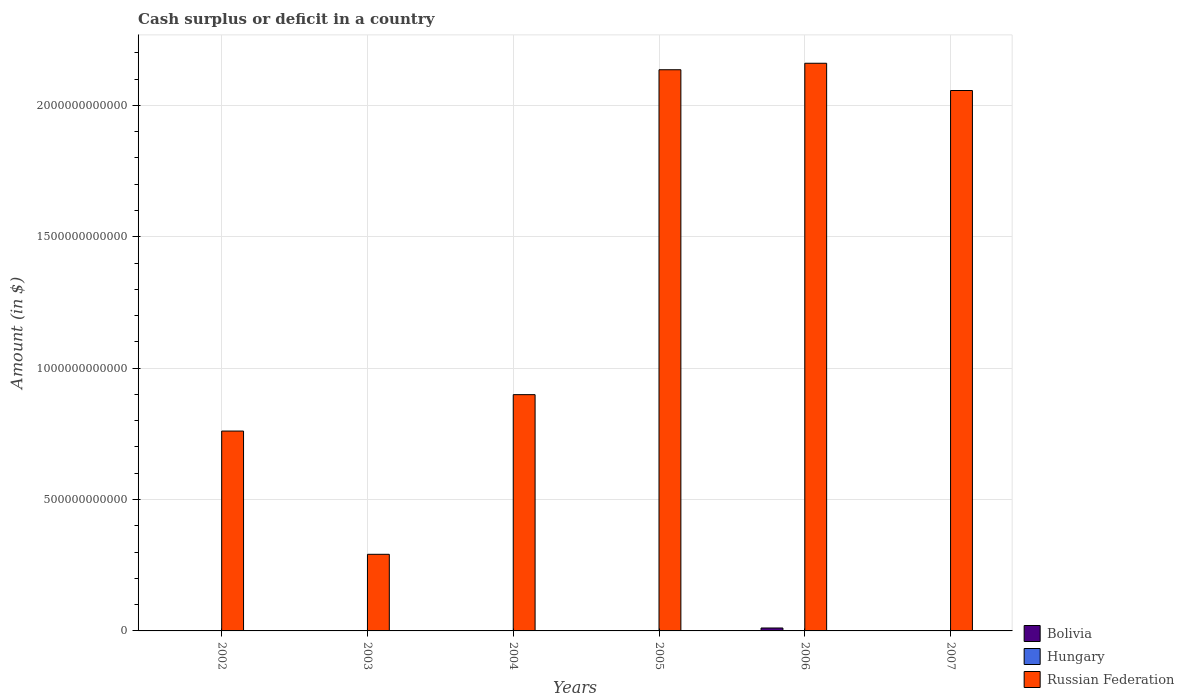Are the number of bars on each tick of the X-axis equal?
Provide a succinct answer. No. How many bars are there on the 1st tick from the left?
Keep it short and to the point. 1. How many bars are there on the 4th tick from the right?
Offer a terse response. 1. What is the amount of cash surplus or deficit in Russian Federation in 2002?
Offer a very short reply. 7.61e+11. Across all years, what is the maximum amount of cash surplus or deficit in Bolivia?
Your answer should be very brief. 1.12e+1. Across all years, what is the minimum amount of cash surplus or deficit in Hungary?
Ensure brevity in your answer.  0. In which year was the amount of cash surplus or deficit in Russian Federation maximum?
Give a very brief answer. 2006. What is the total amount of cash surplus or deficit in Russian Federation in the graph?
Give a very brief answer. 8.30e+12. What is the difference between the amount of cash surplus or deficit in Russian Federation in 2005 and that in 2006?
Your answer should be compact. -2.47e+1. What is the difference between the amount of cash surplus or deficit in Bolivia in 2003 and the amount of cash surplus or deficit in Russian Federation in 2005?
Keep it short and to the point. -2.14e+12. What is the average amount of cash surplus or deficit in Bolivia per year?
Give a very brief answer. 2.07e+09. In the year 2006, what is the difference between the amount of cash surplus or deficit in Bolivia and amount of cash surplus or deficit in Russian Federation?
Ensure brevity in your answer.  -2.15e+12. What is the ratio of the amount of cash surplus or deficit in Russian Federation in 2002 to that in 2004?
Your answer should be very brief. 0.85. Is the amount of cash surplus or deficit in Russian Federation in 2002 less than that in 2007?
Offer a very short reply. Yes. What is the difference between the highest and the second highest amount of cash surplus or deficit in Russian Federation?
Your answer should be compact. 2.47e+1. What is the difference between the highest and the lowest amount of cash surplus or deficit in Bolivia?
Offer a very short reply. 1.12e+1. Is the sum of the amount of cash surplus or deficit in Russian Federation in 2005 and 2006 greater than the maximum amount of cash surplus or deficit in Bolivia across all years?
Provide a short and direct response. Yes. How many bars are there?
Provide a short and direct response. 8. Are all the bars in the graph horizontal?
Provide a short and direct response. No. What is the difference between two consecutive major ticks on the Y-axis?
Offer a terse response. 5.00e+11. Are the values on the major ticks of Y-axis written in scientific E-notation?
Provide a succinct answer. No. Does the graph contain grids?
Your answer should be compact. Yes. How are the legend labels stacked?
Make the answer very short. Vertical. What is the title of the graph?
Provide a succinct answer. Cash surplus or deficit in a country. What is the label or title of the X-axis?
Your answer should be very brief. Years. What is the label or title of the Y-axis?
Keep it short and to the point. Amount (in $). What is the Amount (in $) of Bolivia in 2002?
Provide a short and direct response. 0. What is the Amount (in $) in Russian Federation in 2002?
Make the answer very short. 7.61e+11. What is the Amount (in $) in Bolivia in 2003?
Keep it short and to the point. 0. What is the Amount (in $) in Russian Federation in 2003?
Provide a short and direct response. 2.92e+11. What is the Amount (in $) in Hungary in 2004?
Keep it short and to the point. 0. What is the Amount (in $) of Russian Federation in 2004?
Your response must be concise. 8.99e+11. What is the Amount (in $) of Bolivia in 2005?
Your answer should be compact. 0. What is the Amount (in $) in Hungary in 2005?
Offer a terse response. 0. What is the Amount (in $) of Russian Federation in 2005?
Ensure brevity in your answer.  2.14e+12. What is the Amount (in $) in Bolivia in 2006?
Your answer should be very brief. 1.12e+1. What is the Amount (in $) in Hungary in 2006?
Give a very brief answer. 0. What is the Amount (in $) of Russian Federation in 2006?
Make the answer very short. 2.16e+12. What is the Amount (in $) of Bolivia in 2007?
Your answer should be compact. 1.28e+09. What is the Amount (in $) of Russian Federation in 2007?
Ensure brevity in your answer.  2.06e+12. Across all years, what is the maximum Amount (in $) of Bolivia?
Your answer should be very brief. 1.12e+1. Across all years, what is the maximum Amount (in $) of Russian Federation?
Offer a terse response. 2.16e+12. Across all years, what is the minimum Amount (in $) of Russian Federation?
Provide a succinct answer. 2.92e+11. What is the total Amount (in $) in Bolivia in the graph?
Offer a terse response. 1.24e+1. What is the total Amount (in $) of Russian Federation in the graph?
Give a very brief answer. 8.30e+12. What is the difference between the Amount (in $) in Russian Federation in 2002 and that in 2003?
Ensure brevity in your answer.  4.69e+11. What is the difference between the Amount (in $) in Russian Federation in 2002 and that in 2004?
Ensure brevity in your answer.  -1.39e+11. What is the difference between the Amount (in $) in Russian Federation in 2002 and that in 2005?
Your response must be concise. -1.38e+12. What is the difference between the Amount (in $) of Russian Federation in 2002 and that in 2006?
Give a very brief answer. -1.40e+12. What is the difference between the Amount (in $) of Russian Federation in 2002 and that in 2007?
Provide a short and direct response. -1.30e+12. What is the difference between the Amount (in $) of Russian Federation in 2003 and that in 2004?
Your response must be concise. -6.08e+11. What is the difference between the Amount (in $) in Russian Federation in 2003 and that in 2005?
Your answer should be compact. -1.84e+12. What is the difference between the Amount (in $) in Russian Federation in 2003 and that in 2006?
Provide a short and direct response. -1.87e+12. What is the difference between the Amount (in $) of Russian Federation in 2003 and that in 2007?
Provide a short and direct response. -1.77e+12. What is the difference between the Amount (in $) in Russian Federation in 2004 and that in 2005?
Your answer should be compact. -1.24e+12. What is the difference between the Amount (in $) of Russian Federation in 2004 and that in 2006?
Give a very brief answer. -1.26e+12. What is the difference between the Amount (in $) of Russian Federation in 2004 and that in 2007?
Your response must be concise. -1.16e+12. What is the difference between the Amount (in $) of Russian Federation in 2005 and that in 2006?
Offer a very short reply. -2.47e+1. What is the difference between the Amount (in $) in Russian Federation in 2005 and that in 2007?
Your answer should be compact. 7.90e+1. What is the difference between the Amount (in $) in Bolivia in 2006 and that in 2007?
Offer a terse response. 9.88e+09. What is the difference between the Amount (in $) in Russian Federation in 2006 and that in 2007?
Offer a terse response. 1.04e+11. What is the difference between the Amount (in $) of Bolivia in 2006 and the Amount (in $) of Russian Federation in 2007?
Your answer should be compact. -2.05e+12. What is the average Amount (in $) in Bolivia per year?
Offer a very short reply. 2.07e+09. What is the average Amount (in $) in Hungary per year?
Keep it short and to the point. 0. What is the average Amount (in $) in Russian Federation per year?
Provide a succinct answer. 1.38e+12. In the year 2006, what is the difference between the Amount (in $) of Bolivia and Amount (in $) of Russian Federation?
Ensure brevity in your answer.  -2.15e+12. In the year 2007, what is the difference between the Amount (in $) in Bolivia and Amount (in $) in Russian Federation?
Your answer should be very brief. -2.06e+12. What is the ratio of the Amount (in $) in Russian Federation in 2002 to that in 2003?
Ensure brevity in your answer.  2.61. What is the ratio of the Amount (in $) of Russian Federation in 2002 to that in 2004?
Give a very brief answer. 0.85. What is the ratio of the Amount (in $) in Russian Federation in 2002 to that in 2005?
Keep it short and to the point. 0.36. What is the ratio of the Amount (in $) in Russian Federation in 2002 to that in 2006?
Provide a short and direct response. 0.35. What is the ratio of the Amount (in $) of Russian Federation in 2002 to that in 2007?
Give a very brief answer. 0.37. What is the ratio of the Amount (in $) in Russian Federation in 2003 to that in 2004?
Your answer should be compact. 0.32. What is the ratio of the Amount (in $) of Russian Federation in 2003 to that in 2005?
Your answer should be compact. 0.14. What is the ratio of the Amount (in $) in Russian Federation in 2003 to that in 2006?
Provide a succinct answer. 0.14. What is the ratio of the Amount (in $) in Russian Federation in 2003 to that in 2007?
Ensure brevity in your answer.  0.14. What is the ratio of the Amount (in $) in Russian Federation in 2004 to that in 2005?
Make the answer very short. 0.42. What is the ratio of the Amount (in $) of Russian Federation in 2004 to that in 2006?
Your response must be concise. 0.42. What is the ratio of the Amount (in $) in Russian Federation in 2004 to that in 2007?
Make the answer very short. 0.44. What is the ratio of the Amount (in $) in Russian Federation in 2005 to that in 2007?
Make the answer very short. 1.04. What is the ratio of the Amount (in $) in Bolivia in 2006 to that in 2007?
Your answer should be compact. 8.72. What is the ratio of the Amount (in $) of Russian Federation in 2006 to that in 2007?
Offer a very short reply. 1.05. What is the difference between the highest and the second highest Amount (in $) in Russian Federation?
Make the answer very short. 2.47e+1. What is the difference between the highest and the lowest Amount (in $) in Bolivia?
Provide a short and direct response. 1.12e+1. What is the difference between the highest and the lowest Amount (in $) in Russian Federation?
Offer a very short reply. 1.87e+12. 